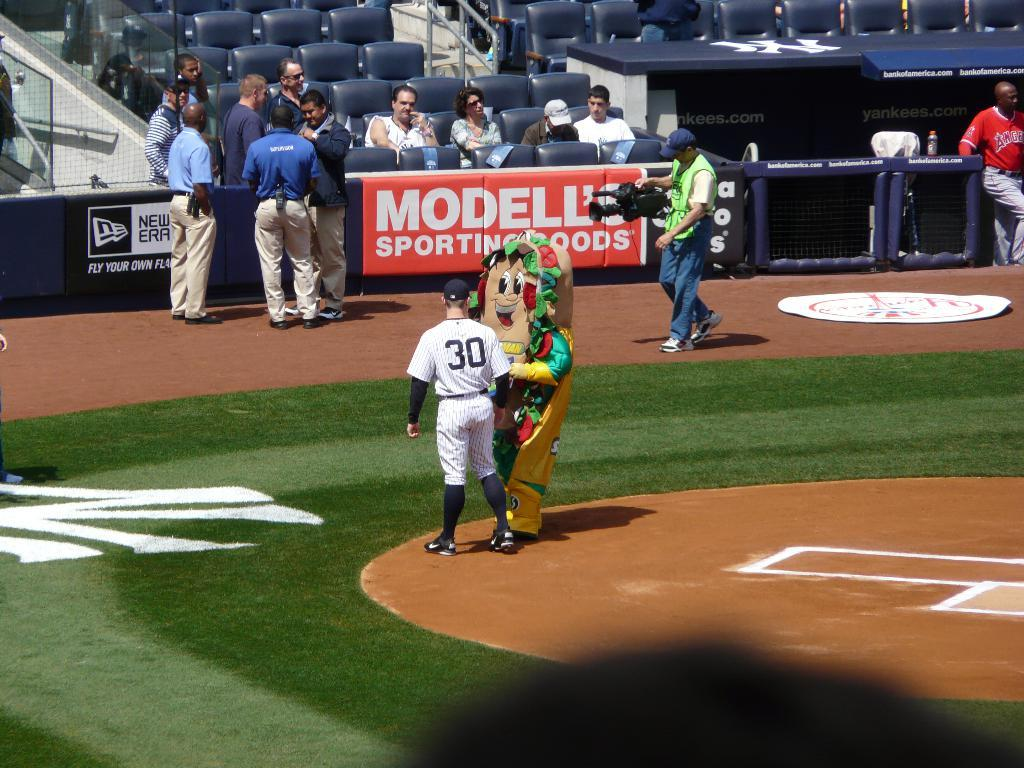<image>
Give a short and clear explanation of the subsequent image. A sports field with a man in a number thirty shirt next to a mascot. 